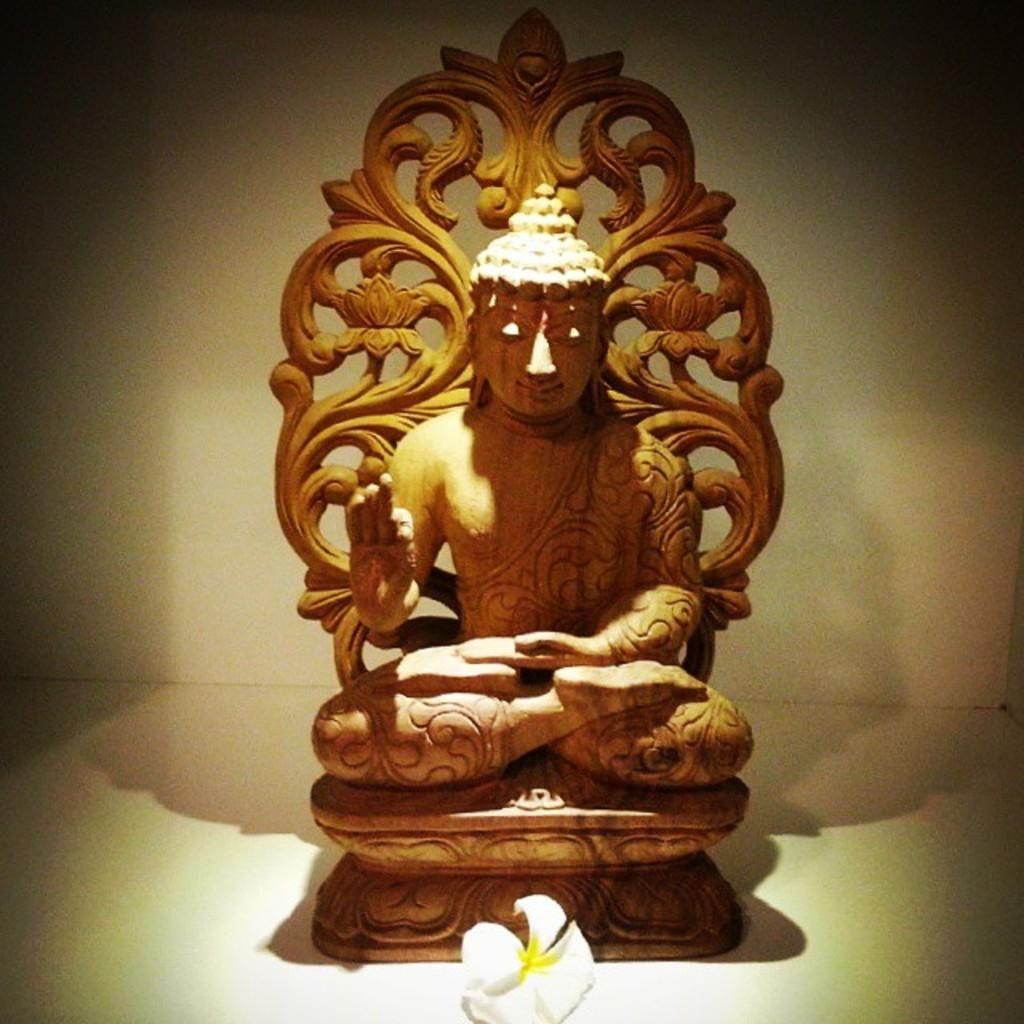What is the color of the statue in the image? The statue in the image is brown. What types of flowers can be seen in the image? There are white and yellow color flowers in the image. What is the color of the floor in the image? The floor in the image is white. Can you tell me how many ducks are swimming in the water near the statue? There are no ducks present in the image; it only features a brown statue, white and yellow flowers, and a white floor. Is there a boy playing with the flowers in the image? There is no boy present in the image; it only features a brown statue, white and yellow flowers, and a white floor. 